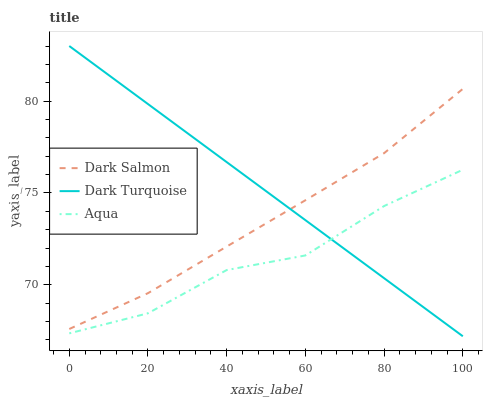Does Aqua have the minimum area under the curve?
Answer yes or no. Yes. Does Dark Turquoise have the maximum area under the curve?
Answer yes or no. Yes. Does Dark Salmon have the minimum area under the curve?
Answer yes or no. No. Does Dark Salmon have the maximum area under the curve?
Answer yes or no. No. Is Dark Turquoise the smoothest?
Answer yes or no. Yes. Is Aqua the roughest?
Answer yes or no. Yes. Is Dark Salmon the smoothest?
Answer yes or no. No. Is Dark Salmon the roughest?
Answer yes or no. No. Does Aqua have the lowest value?
Answer yes or no. No. Does Dark Turquoise have the highest value?
Answer yes or no. Yes. Does Dark Salmon have the highest value?
Answer yes or no. No. Is Aqua less than Dark Salmon?
Answer yes or no. Yes. Is Dark Salmon greater than Aqua?
Answer yes or no. Yes. Does Dark Turquoise intersect Dark Salmon?
Answer yes or no. Yes. Is Dark Turquoise less than Dark Salmon?
Answer yes or no. No. Is Dark Turquoise greater than Dark Salmon?
Answer yes or no. No. Does Aqua intersect Dark Salmon?
Answer yes or no. No. 